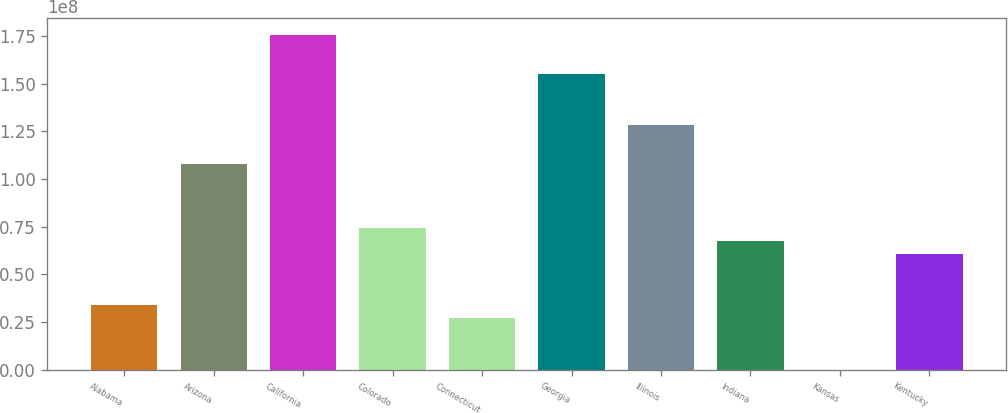Convert chart. <chart><loc_0><loc_0><loc_500><loc_500><bar_chart><fcel>Alabama<fcel>Arizona<fcel>California<fcel>Colorado<fcel>Connecticut<fcel>Georgia<fcel>Illinois<fcel>Indiana<fcel>Kansas<fcel>Kentucky<nl><fcel>3.37965e+07<fcel>1.08039e+08<fcel>1.75532e+08<fcel>7.42922e+07<fcel>2.70472e+07<fcel>1.55284e+08<fcel>1.28287e+08<fcel>6.75429e+07<fcel>49999<fcel>6.07936e+07<nl></chart> 